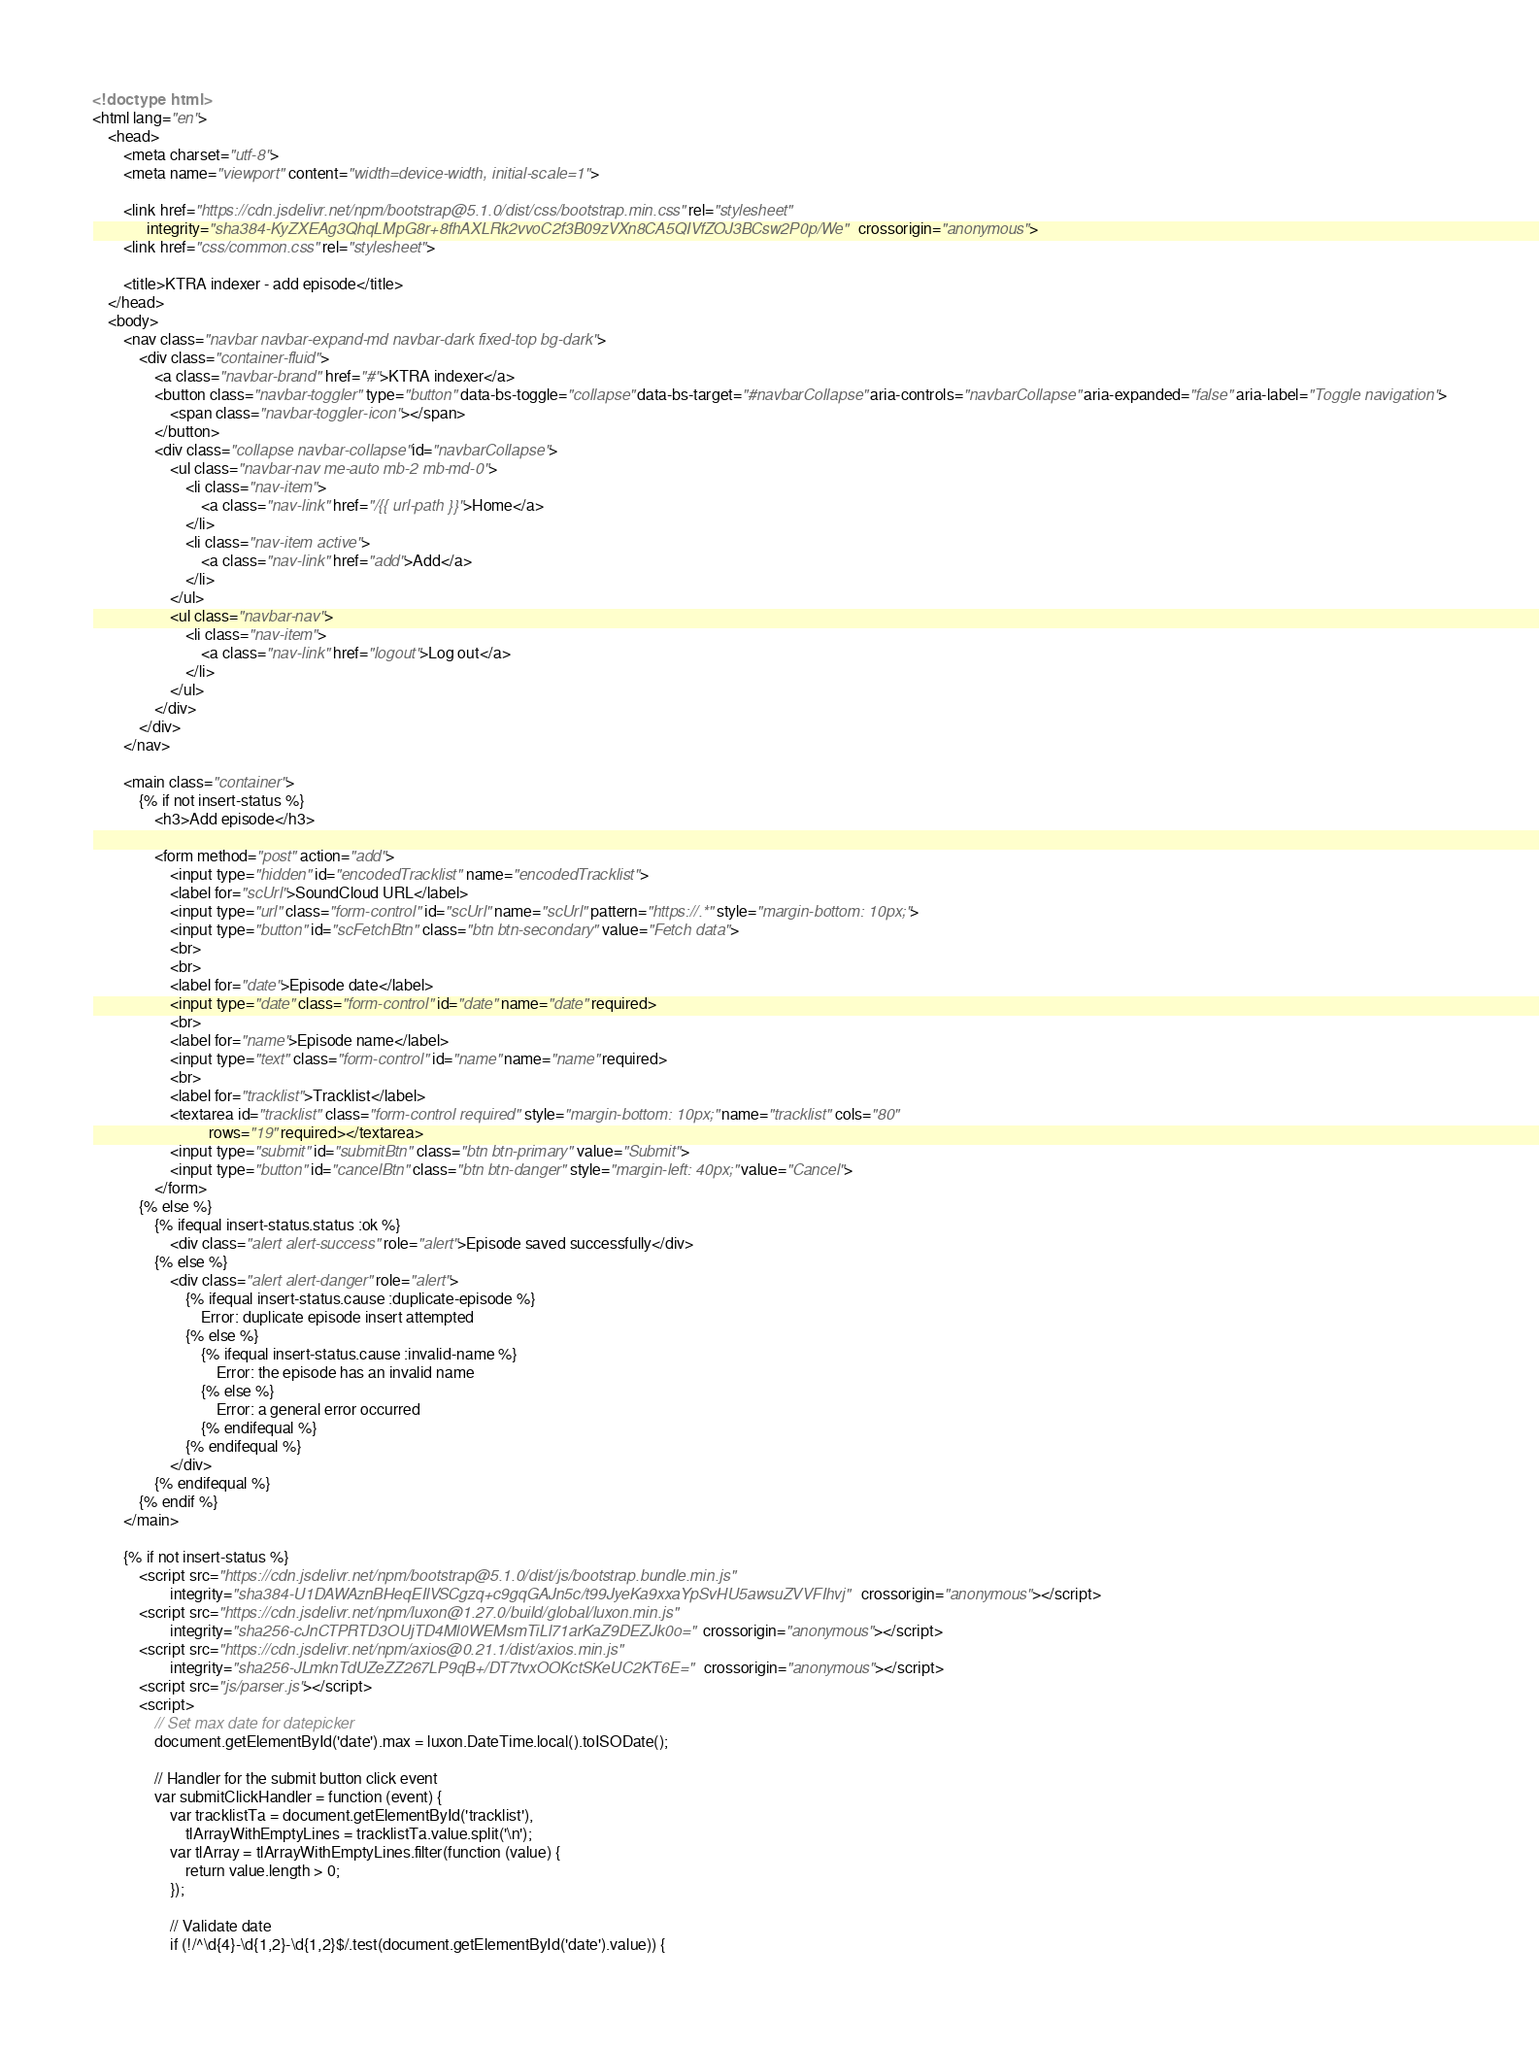<code> <loc_0><loc_0><loc_500><loc_500><_HTML_><!doctype html>
<html lang="en">
    <head>
        <meta charset="utf-8">
        <meta name="viewport" content="width=device-width, initial-scale=1">

        <link href="https://cdn.jsdelivr.net/npm/bootstrap@5.1.0/dist/css/bootstrap.min.css" rel="stylesheet"
              integrity="sha384-KyZXEAg3QhqLMpG8r+8fhAXLRk2vvoC2f3B09zVXn8CA5QIVfZOJ3BCsw2P0p/We" crossorigin="anonymous">
        <link href="css/common.css" rel="stylesheet">

        <title>KTRA indexer - add episode</title>
    </head>
    <body>
        <nav class="navbar navbar-expand-md navbar-dark fixed-top bg-dark">
            <div class="container-fluid">
                <a class="navbar-brand" href="#">KTRA indexer</a>
                <button class="navbar-toggler" type="button" data-bs-toggle="collapse" data-bs-target="#navbarCollapse" aria-controls="navbarCollapse" aria-expanded="false" aria-label="Toggle navigation">
                    <span class="navbar-toggler-icon"></span>
                </button>
                <div class="collapse navbar-collapse" id="navbarCollapse">
                    <ul class="navbar-nav me-auto mb-2 mb-md-0">
                        <li class="nav-item">
                            <a class="nav-link" href="/{{ url-path }}">Home</a>
                        </li>
                        <li class="nav-item active">
                            <a class="nav-link" href="add">Add</a>
                        </li>
                    </ul>
                    <ul class="navbar-nav">
                        <li class="nav-item">
                            <a class="nav-link" href="logout">Log out</a>
                        </li>
                    </ul>
                </div>
            </div>
        </nav>

        <main class="container">
            {% if not insert-status %}
                <h3>Add episode</h3>

                <form method="post" action="add">
                    <input type="hidden" id="encodedTracklist" name="encodedTracklist">
                    <label for="scUrl">SoundCloud URL</label>
                    <input type="url" class="form-control" id="scUrl" name="scUrl" pattern="https://.*" style="margin-bottom: 10px;">
                    <input type="button" id="scFetchBtn" class="btn btn-secondary" value="Fetch data">
                    <br>
                    <br>
                    <label for="date">Episode date</label>
                    <input type="date" class="form-control" id="date" name="date" required>
                    <br>
                    <label for="name">Episode name</label>
                    <input type="text" class="form-control" id="name" name="name" required>
                    <br>
                    <label for="tracklist">Tracklist</label>
                    <textarea id="tracklist" class="form-control required" style="margin-bottom: 10px;" name="tracklist" cols="80"
                              rows="19" required></textarea>
                    <input type="submit" id="submitBtn" class="btn btn-primary" value="Submit">
                    <input type="button" id="cancelBtn" class="btn btn-danger" style="margin-left: 40px;" value="Cancel">
                </form>
            {% else %}
                {% ifequal insert-status.status :ok %}
                    <div class="alert alert-success" role="alert">Episode saved successfully</div>
                {% else %}
                    <div class="alert alert-danger" role="alert">
                        {% ifequal insert-status.cause :duplicate-episode %}
                            Error: duplicate episode insert attempted
                        {% else %}
                            {% ifequal insert-status.cause :invalid-name %}
                                Error: the episode has an invalid name
                            {% else %}
                                Error: a general error occurred
                            {% endifequal %}
                        {% endifequal %}
                    </div>
                {% endifequal %}
            {% endif %}
        </main>

        {% if not insert-status %}
            <script src="https://cdn.jsdelivr.net/npm/bootstrap@5.1.0/dist/js/bootstrap.bundle.min.js"
                    integrity="sha384-U1DAWAznBHeqEIlVSCgzq+c9gqGAJn5c/t99JyeKa9xxaYpSvHU5awsuZVVFIhvj" crossorigin="anonymous"></script>
            <script src="https://cdn.jsdelivr.net/npm/luxon@1.27.0/build/global/luxon.min.js"
                    integrity="sha256-cJnCTPRTD3OUjTD4Ml0WEMsmTiLl71arKaZ9DEZJk0o=" crossorigin="anonymous"></script>
            <script src="https://cdn.jsdelivr.net/npm/axios@0.21.1/dist/axios.min.js"
                    integrity="sha256-JLmknTdUZeZZ267LP9qB+/DT7tvxOOKctSKeUC2KT6E=" crossorigin="anonymous"></script>
            <script src="js/parser.js"></script>
            <script>
                // Set max date for datepicker
                document.getElementById('date').max = luxon.DateTime.local().toISODate();

                // Handler for the submit button click event
                var submitClickHandler = function (event) {
                    var tracklistTa = document.getElementById('tracklist'),
                        tlArrayWithEmptyLines = tracklistTa.value.split('\n');
                    var tlArray = tlArrayWithEmptyLines.filter(function (value) {
                        return value.length > 0;
                    });

                    // Validate date
                    if (!/^\d{4}-\d{1,2}-\d{1,2}$/.test(document.getElementById('date').value)) {</code> 